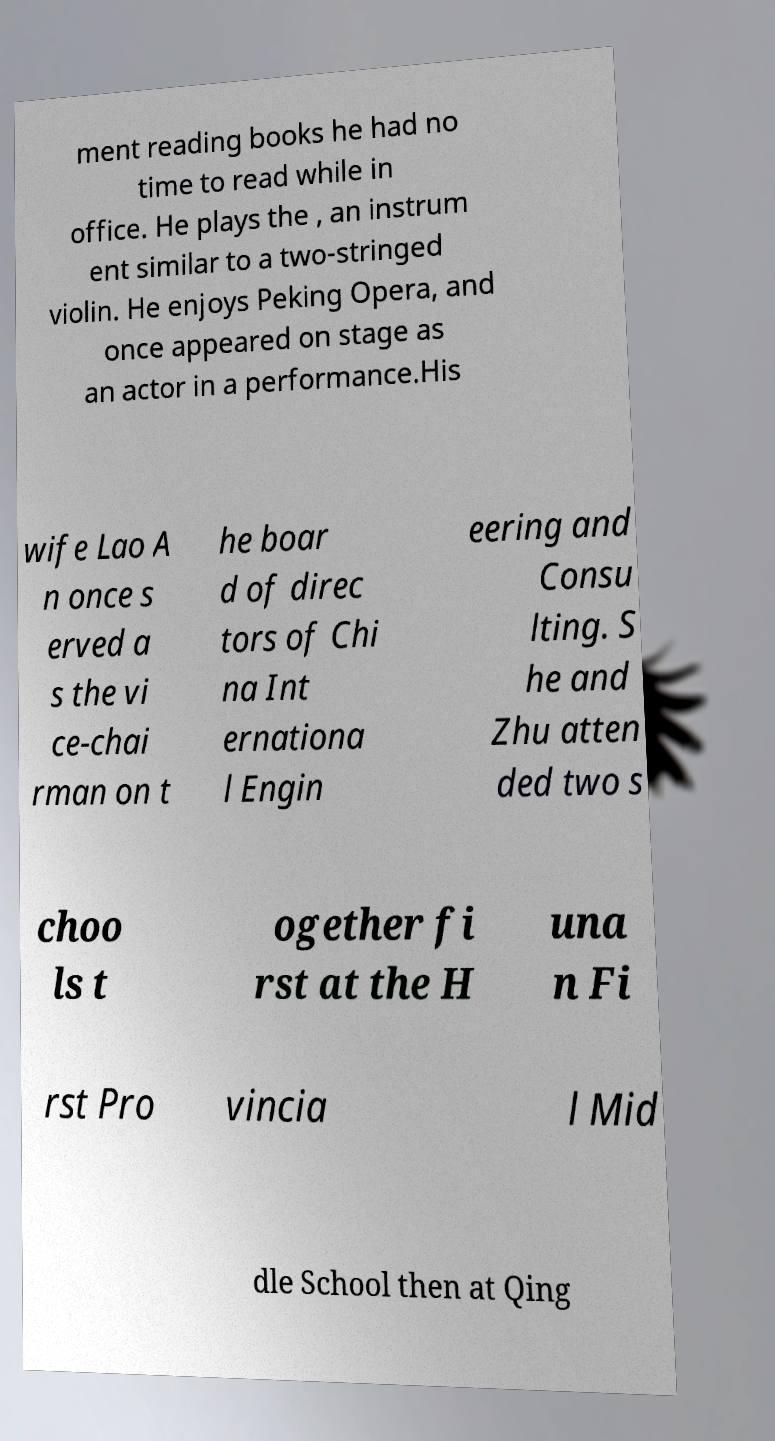I need the written content from this picture converted into text. Can you do that? ment reading books he had no time to read while in office. He plays the , an instrum ent similar to a two-stringed violin. He enjoys Peking Opera, and once appeared on stage as an actor in a performance.His wife Lao A n once s erved a s the vi ce-chai rman on t he boar d of direc tors of Chi na Int ernationa l Engin eering and Consu lting. S he and Zhu atten ded two s choo ls t ogether fi rst at the H una n Fi rst Pro vincia l Mid dle School then at Qing 